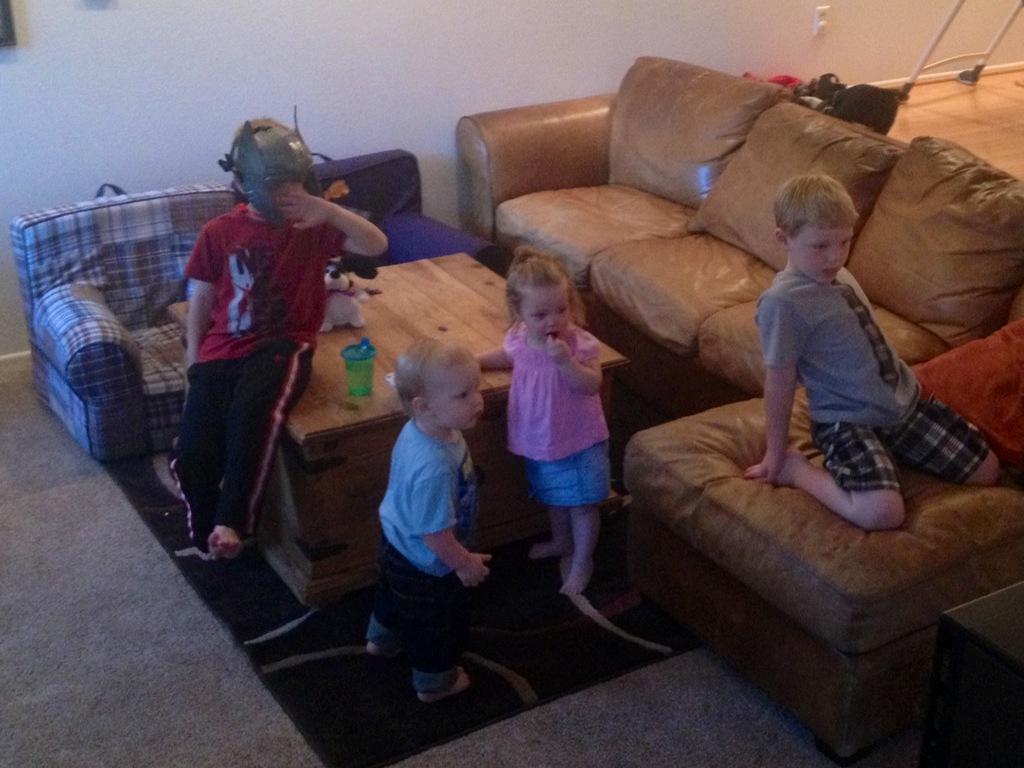Please provide a concise description of this image. Four children are playing in a living room. Two are standing at a table. One is sitting on the table. The other is sitting on sofa. 